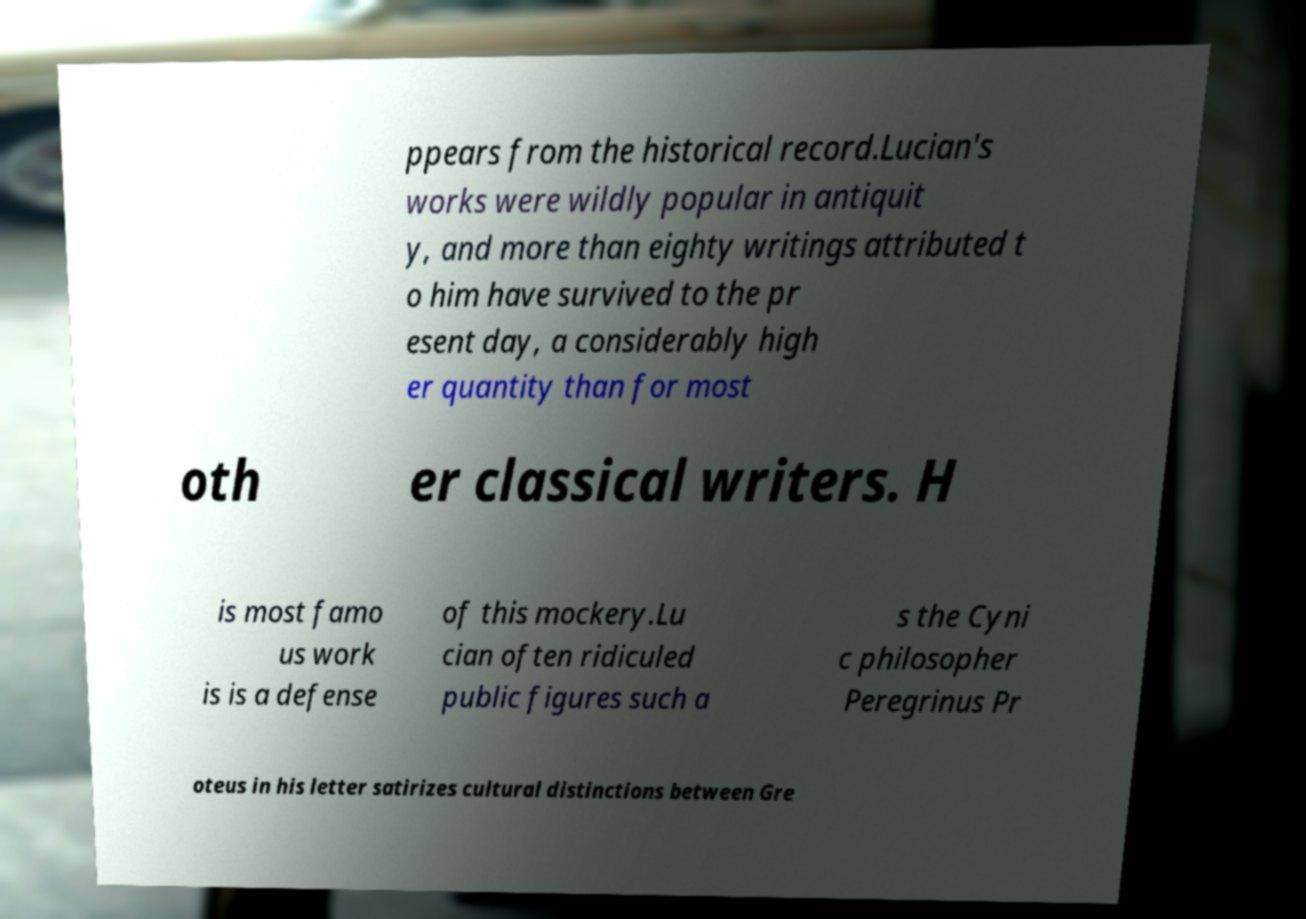Please identify and transcribe the text found in this image. ppears from the historical record.Lucian's works were wildly popular in antiquit y, and more than eighty writings attributed t o him have survived to the pr esent day, a considerably high er quantity than for most oth er classical writers. H is most famo us work is is a defense of this mockery.Lu cian often ridiculed public figures such a s the Cyni c philosopher Peregrinus Pr oteus in his letter satirizes cultural distinctions between Gre 